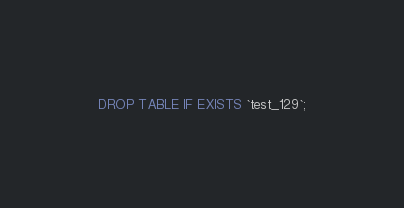Convert code to text. <code><loc_0><loc_0><loc_500><loc_500><_SQL_>DROP TABLE IF EXISTS `test_129`;</code> 